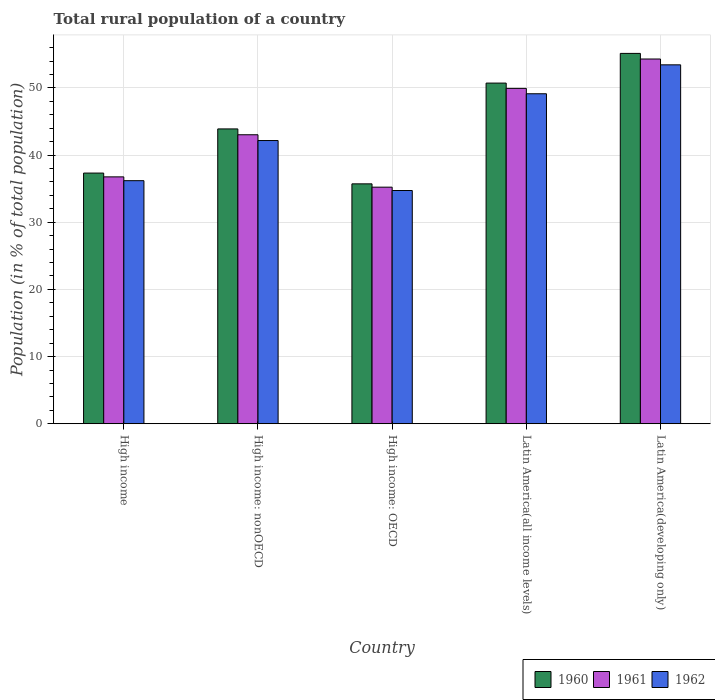How many different coloured bars are there?
Keep it short and to the point. 3. How many groups of bars are there?
Make the answer very short. 5. Are the number of bars per tick equal to the number of legend labels?
Your answer should be very brief. Yes. How many bars are there on the 3rd tick from the right?
Offer a terse response. 3. What is the label of the 4th group of bars from the left?
Keep it short and to the point. Latin America(all income levels). What is the rural population in 1960 in Latin America(all income levels)?
Offer a very short reply. 50.72. Across all countries, what is the maximum rural population in 1961?
Ensure brevity in your answer.  54.3. Across all countries, what is the minimum rural population in 1962?
Keep it short and to the point. 34.72. In which country was the rural population in 1961 maximum?
Give a very brief answer. Latin America(developing only). In which country was the rural population in 1962 minimum?
Offer a very short reply. High income: OECD. What is the total rural population in 1960 in the graph?
Provide a short and direct response. 222.78. What is the difference between the rural population in 1961 in High income and that in Latin America(all income levels)?
Offer a terse response. -13.17. What is the difference between the rural population in 1961 in Latin America(all income levels) and the rural population in 1960 in Latin America(developing only)?
Your answer should be very brief. -5.21. What is the average rural population in 1962 per country?
Your response must be concise. 43.13. What is the difference between the rural population of/in 1962 and rural population of/in 1960 in High income?
Make the answer very short. -1.13. What is the ratio of the rural population in 1961 in High income: OECD to that in Latin America(developing only)?
Your answer should be very brief. 0.65. Is the difference between the rural population in 1962 in High income and Latin America(all income levels) greater than the difference between the rural population in 1960 in High income and Latin America(all income levels)?
Keep it short and to the point. Yes. What is the difference between the highest and the second highest rural population in 1962?
Your response must be concise. 6.97. What is the difference between the highest and the lowest rural population in 1960?
Your answer should be compact. 19.42. In how many countries, is the rural population in 1962 greater than the average rural population in 1962 taken over all countries?
Provide a succinct answer. 2. What does the 1st bar from the left in Latin America(developing only) represents?
Your answer should be compact. 1960. How many countries are there in the graph?
Keep it short and to the point. 5. Are the values on the major ticks of Y-axis written in scientific E-notation?
Your answer should be compact. No. Does the graph contain any zero values?
Make the answer very short. No. How many legend labels are there?
Your answer should be very brief. 3. How are the legend labels stacked?
Your answer should be compact. Horizontal. What is the title of the graph?
Provide a short and direct response. Total rural population of a country. Does "1999" appear as one of the legend labels in the graph?
Give a very brief answer. No. What is the label or title of the X-axis?
Offer a very short reply. Country. What is the label or title of the Y-axis?
Provide a short and direct response. Population (in % of total population). What is the Population (in % of total population) of 1960 in High income?
Make the answer very short. 37.32. What is the Population (in % of total population) of 1961 in High income?
Your answer should be compact. 36.75. What is the Population (in % of total population) in 1962 in High income?
Make the answer very short. 36.19. What is the Population (in % of total population) in 1960 in High income: nonOECD?
Make the answer very short. 43.89. What is the Population (in % of total population) in 1961 in High income: nonOECD?
Keep it short and to the point. 43.02. What is the Population (in % of total population) of 1962 in High income: nonOECD?
Offer a terse response. 42.16. What is the Population (in % of total population) in 1960 in High income: OECD?
Your answer should be very brief. 35.71. What is the Population (in % of total population) of 1961 in High income: OECD?
Your answer should be very brief. 35.22. What is the Population (in % of total population) of 1962 in High income: OECD?
Keep it short and to the point. 34.72. What is the Population (in % of total population) of 1960 in Latin America(all income levels)?
Offer a very short reply. 50.72. What is the Population (in % of total population) of 1961 in Latin America(all income levels)?
Your response must be concise. 49.93. What is the Population (in % of total population) of 1962 in Latin America(all income levels)?
Give a very brief answer. 49.13. What is the Population (in % of total population) of 1960 in Latin America(developing only)?
Your response must be concise. 55.14. What is the Population (in % of total population) of 1961 in Latin America(developing only)?
Keep it short and to the point. 54.3. What is the Population (in % of total population) in 1962 in Latin America(developing only)?
Your answer should be very brief. 53.43. Across all countries, what is the maximum Population (in % of total population) in 1960?
Ensure brevity in your answer.  55.14. Across all countries, what is the maximum Population (in % of total population) of 1961?
Provide a short and direct response. 54.3. Across all countries, what is the maximum Population (in % of total population) in 1962?
Offer a very short reply. 53.43. Across all countries, what is the minimum Population (in % of total population) of 1960?
Your answer should be compact. 35.71. Across all countries, what is the minimum Population (in % of total population) in 1961?
Give a very brief answer. 35.22. Across all countries, what is the minimum Population (in % of total population) of 1962?
Provide a short and direct response. 34.72. What is the total Population (in % of total population) in 1960 in the graph?
Offer a very short reply. 222.78. What is the total Population (in % of total population) of 1961 in the graph?
Offer a terse response. 219.22. What is the total Population (in % of total population) in 1962 in the graph?
Offer a very short reply. 215.63. What is the difference between the Population (in % of total population) in 1960 in High income and that in High income: nonOECD?
Your answer should be very brief. -6.57. What is the difference between the Population (in % of total population) in 1961 in High income and that in High income: nonOECD?
Give a very brief answer. -6.27. What is the difference between the Population (in % of total population) of 1962 in High income and that in High income: nonOECD?
Give a very brief answer. -5.97. What is the difference between the Population (in % of total population) of 1960 in High income and that in High income: OECD?
Make the answer very short. 1.61. What is the difference between the Population (in % of total population) in 1961 in High income and that in High income: OECD?
Provide a succinct answer. 1.53. What is the difference between the Population (in % of total population) of 1962 in High income and that in High income: OECD?
Your answer should be compact. 1.46. What is the difference between the Population (in % of total population) in 1960 in High income and that in Latin America(all income levels)?
Offer a very short reply. -13.4. What is the difference between the Population (in % of total population) in 1961 in High income and that in Latin America(all income levels)?
Make the answer very short. -13.17. What is the difference between the Population (in % of total population) of 1962 in High income and that in Latin America(all income levels)?
Your response must be concise. -12.94. What is the difference between the Population (in % of total population) in 1960 in High income and that in Latin America(developing only)?
Ensure brevity in your answer.  -17.82. What is the difference between the Population (in % of total population) in 1961 in High income and that in Latin America(developing only)?
Give a very brief answer. -17.55. What is the difference between the Population (in % of total population) in 1962 in High income and that in Latin America(developing only)?
Offer a terse response. -17.25. What is the difference between the Population (in % of total population) in 1960 in High income: nonOECD and that in High income: OECD?
Your response must be concise. 8.18. What is the difference between the Population (in % of total population) in 1961 in High income: nonOECD and that in High income: OECD?
Ensure brevity in your answer.  7.8. What is the difference between the Population (in % of total population) in 1962 in High income: nonOECD and that in High income: OECD?
Offer a very short reply. 7.44. What is the difference between the Population (in % of total population) of 1960 in High income: nonOECD and that in Latin America(all income levels)?
Keep it short and to the point. -6.82. What is the difference between the Population (in % of total population) of 1961 in High income: nonOECD and that in Latin America(all income levels)?
Provide a succinct answer. -6.9. What is the difference between the Population (in % of total population) in 1962 in High income: nonOECD and that in Latin America(all income levels)?
Offer a very short reply. -6.97. What is the difference between the Population (in % of total population) of 1960 in High income: nonOECD and that in Latin America(developing only)?
Your answer should be compact. -11.24. What is the difference between the Population (in % of total population) of 1961 in High income: nonOECD and that in Latin America(developing only)?
Your answer should be very brief. -11.28. What is the difference between the Population (in % of total population) of 1962 in High income: nonOECD and that in Latin America(developing only)?
Provide a short and direct response. -11.27. What is the difference between the Population (in % of total population) of 1960 in High income: OECD and that in Latin America(all income levels)?
Keep it short and to the point. -15. What is the difference between the Population (in % of total population) of 1961 in High income: OECD and that in Latin America(all income levels)?
Provide a succinct answer. -14.71. What is the difference between the Population (in % of total population) of 1962 in High income: OECD and that in Latin America(all income levels)?
Offer a very short reply. -14.4. What is the difference between the Population (in % of total population) of 1960 in High income: OECD and that in Latin America(developing only)?
Offer a terse response. -19.42. What is the difference between the Population (in % of total population) of 1961 in High income: OECD and that in Latin America(developing only)?
Your response must be concise. -19.08. What is the difference between the Population (in % of total population) of 1962 in High income: OECD and that in Latin America(developing only)?
Your answer should be very brief. -18.71. What is the difference between the Population (in % of total population) of 1960 in Latin America(all income levels) and that in Latin America(developing only)?
Give a very brief answer. -4.42. What is the difference between the Population (in % of total population) of 1961 in Latin America(all income levels) and that in Latin America(developing only)?
Your response must be concise. -4.37. What is the difference between the Population (in % of total population) of 1962 in Latin America(all income levels) and that in Latin America(developing only)?
Your answer should be compact. -4.31. What is the difference between the Population (in % of total population) in 1960 in High income and the Population (in % of total population) in 1961 in High income: nonOECD?
Offer a very short reply. -5.7. What is the difference between the Population (in % of total population) of 1960 in High income and the Population (in % of total population) of 1962 in High income: nonOECD?
Provide a succinct answer. -4.84. What is the difference between the Population (in % of total population) of 1961 in High income and the Population (in % of total population) of 1962 in High income: nonOECD?
Provide a succinct answer. -5.41. What is the difference between the Population (in % of total population) in 1960 in High income and the Population (in % of total population) in 1961 in High income: OECD?
Ensure brevity in your answer.  2.1. What is the difference between the Population (in % of total population) in 1960 in High income and the Population (in % of total population) in 1962 in High income: OECD?
Make the answer very short. 2.6. What is the difference between the Population (in % of total population) in 1961 in High income and the Population (in % of total population) in 1962 in High income: OECD?
Your answer should be very brief. 2.03. What is the difference between the Population (in % of total population) of 1960 in High income and the Population (in % of total population) of 1961 in Latin America(all income levels)?
Your response must be concise. -12.61. What is the difference between the Population (in % of total population) in 1960 in High income and the Population (in % of total population) in 1962 in Latin America(all income levels)?
Keep it short and to the point. -11.81. What is the difference between the Population (in % of total population) in 1961 in High income and the Population (in % of total population) in 1962 in Latin America(all income levels)?
Keep it short and to the point. -12.37. What is the difference between the Population (in % of total population) in 1960 in High income and the Population (in % of total population) in 1961 in Latin America(developing only)?
Offer a very short reply. -16.98. What is the difference between the Population (in % of total population) in 1960 in High income and the Population (in % of total population) in 1962 in Latin America(developing only)?
Provide a short and direct response. -16.11. What is the difference between the Population (in % of total population) in 1961 in High income and the Population (in % of total population) in 1962 in Latin America(developing only)?
Offer a very short reply. -16.68. What is the difference between the Population (in % of total population) in 1960 in High income: nonOECD and the Population (in % of total population) in 1961 in High income: OECD?
Your response must be concise. 8.67. What is the difference between the Population (in % of total population) in 1960 in High income: nonOECD and the Population (in % of total population) in 1962 in High income: OECD?
Give a very brief answer. 9.17. What is the difference between the Population (in % of total population) in 1961 in High income: nonOECD and the Population (in % of total population) in 1962 in High income: OECD?
Provide a succinct answer. 8.3. What is the difference between the Population (in % of total population) of 1960 in High income: nonOECD and the Population (in % of total population) of 1961 in Latin America(all income levels)?
Provide a short and direct response. -6.03. What is the difference between the Population (in % of total population) in 1960 in High income: nonOECD and the Population (in % of total population) in 1962 in Latin America(all income levels)?
Your answer should be compact. -5.24. What is the difference between the Population (in % of total population) of 1961 in High income: nonOECD and the Population (in % of total population) of 1962 in Latin America(all income levels)?
Make the answer very short. -6.1. What is the difference between the Population (in % of total population) of 1960 in High income: nonOECD and the Population (in % of total population) of 1961 in Latin America(developing only)?
Offer a very short reply. -10.41. What is the difference between the Population (in % of total population) of 1960 in High income: nonOECD and the Population (in % of total population) of 1962 in Latin America(developing only)?
Make the answer very short. -9.54. What is the difference between the Population (in % of total population) in 1961 in High income: nonOECD and the Population (in % of total population) in 1962 in Latin America(developing only)?
Your response must be concise. -10.41. What is the difference between the Population (in % of total population) of 1960 in High income: OECD and the Population (in % of total population) of 1961 in Latin America(all income levels)?
Your response must be concise. -14.21. What is the difference between the Population (in % of total population) of 1960 in High income: OECD and the Population (in % of total population) of 1962 in Latin America(all income levels)?
Ensure brevity in your answer.  -13.41. What is the difference between the Population (in % of total population) of 1961 in High income: OECD and the Population (in % of total population) of 1962 in Latin America(all income levels)?
Offer a very short reply. -13.91. What is the difference between the Population (in % of total population) of 1960 in High income: OECD and the Population (in % of total population) of 1961 in Latin America(developing only)?
Your answer should be compact. -18.59. What is the difference between the Population (in % of total population) in 1960 in High income: OECD and the Population (in % of total population) in 1962 in Latin America(developing only)?
Keep it short and to the point. -17.72. What is the difference between the Population (in % of total population) in 1961 in High income: OECD and the Population (in % of total population) in 1962 in Latin America(developing only)?
Give a very brief answer. -18.21. What is the difference between the Population (in % of total population) in 1960 in Latin America(all income levels) and the Population (in % of total population) in 1961 in Latin America(developing only)?
Provide a short and direct response. -3.58. What is the difference between the Population (in % of total population) of 1960 in Latin America(all income levels) and the Population (in % of total population) of 1962 in Latin America(developing only)?
Keep it short and to the point. -2.72. What is the difference between the Population (in % of total population) in 1961 in Latin America(all income levels) and the Population (in % of total population) in 1962 in Latin America(developing only)?
Make the answer very short. -3.51. What is the average Population (in % of total population) of 1960 per country?
Your answer should be compact. 44.56. What is the average Population (in % of total population) of 1961 per country?
Ensure brevity in your answer.  43.84. What is the average Population (in % of total population) of 1962 per country?
Your answer should be compact. 43.13. What is the difference between the Population (in % of total population) in 1960 and Population (in % of total population) in 1961 in High income?
Your answer should be very brief. 0.57. What is the difference between the Population (in % of total population) of 1960 and Population (in % of total population) of 1962 in High income?
Provide a succinct answer. 1.13. What is the difference between the Population (in % of total population) in 1961 and Population (in % of total population) in 1962 in High income?
Offer a terse response. 0.57. What is the difference between the Population (in % of total population) of 1960 and Population (in % of total population) of 1961 in High income: nonOECD?
Provide a succinct answer. 0.87. What is the difference between the Population (in % of total population) in 1960 and Population (in % of total population) in 1962 in High income: nonOECD?
Offer a terse response. 1.73. What is the difference between the Population (in % of total population) in 1961 and Population (in % of total population) in 1962 in High income: nonOECD?
Your answer should be compact. 0.86. What is the difference between the Population (in % of total population) of 1960 and Population (in % of total population) of 1961 in High income: OECD?
Provide a succinct answer. 0.49. What is the difference between the Population (in % of total population) in 1960 and Population (in % of total population) in 1962 in High income: OECD?
Give a very brief answer. 0.99. What is the difference between the Population (in % of total population) of 1961 and Population (in % of total population) of 1962 in High income: OECD?
Your response must be concise. 0.5. What is the difference between the Population (in % of total population) of 1960 and Population (in % of total population) of 1961 in Latin America(all income levels)?
Provide a short and direct response. 0.79. What is the difference between the Population (in % of total population) in 1960 and Population (in % of total population) in 1962 in Latin America(all income levels)?
Your answer should be compact. 1.59. What is the difference between the Population (in % of total population) of 1961 and Population (in % of total population) of 1962 in Latin America(all income levels)?
Give a very brief answer. 0.8. What is the difference between the Population (in % of total population) in 1960 and Population (in % of total population) in 1961 in Latin America(developing only)?
Ensure brevity in your answer.  0.84. What is the difference between the Population (in % of total population) in 1960 and Population (in % of total population) in 1962 in Latin America(developing only)?
Provide a short and direct response. 1.7. What is the difference between the Population (in % of total population) in 1961 and Population (in % of total population) in 1962 in Latin America(developing only)?
Offer a terse response. 0.87. What is the ratio of the Population (in % of total population) in 1960 in High income to that in High income: nonOECD?
Your answer should be very brief. 0.85. What is the ratio of the Population (in % of total population) in 1961 in High income to that in High income: nonOECD?
Keep it short and to the point. 0.85. What is the ratio of the Population (in % of total population) in 1962 in High income to that in High income: nonOECD?
Offer a terse response. 0.86. What is the ratio of the Population (in % of total population) of 1960 in High income to that in High income: OECD?
Your response must be concise. 1.04. What is the ratio of the Population (in % of total population) of 1961 in High income to that in High income: OECD?
Keep it short and to the point. 1.04. What is the ratio of the Population (in % of total population) in 1962 in High income to that in High income: OECD?
Your answer should be very brief. 1.04. What is the ratio of the Population (in % of total population) of 1960 in High income to that in Latin America(all income levels)?
Your response must be concise. 0.74. What is the ratio of the Population (in % of total population) in 1961 in High income to that in Latin America(all income levels)?
Your answer should be very brief. 0.74. What is the ratio of the Population (in % of total population) in 1962 in High income to that in Latin America(all income levels)?
Provide a succinct answer. 0.74. What is the ratio of the Population (in % of total population) in 1960 in High income to that in Latin America(developing only)?
Make the answer very short. 0.68. What is the ratio of the Population (in % of total population) of 1961 in High income to that in Latin America(developing only)?
Your answer should be very brief. 0.68. What is the ratio of the Population (in % of total population) of 1962 in High income to that in Latin America(developing only)?
Offer a very short reply. 0.68. What is the ratio of the Population (in % of total population) in 1960 in High income: nonOECD to that in High income: OECD?
Keep it short and to the point. 1.23. What is the ratio of the Population (in % of total population) in 1961 in High income: nonOECD to that in High income: OECD?
Provide a succinct answer. 1.22. What is the ratio of the Population (in % of total population) of 1962 in High income: nonOECD to that in High income: OECD?
Ensure brevity in your answer.  1.21. What is the ratio of the Population (in % of total population) in 1960 in High income: nonOECD to that in Latin America(all income levels)?
Your answer should be very brief. 0.87. What is the ratio of the Population (in % of total population) of 1961 in High income: nonOECD to that in Latin America(all income levels)?
Ensure brevity in your answer.  0.86. What is the ratio of the Population (in % of total population) of 1962 in High income: nonOECD to that in Latin America(all income levels)?
Your answer should be compact. 0.86. What is the ratio of the Population (in % of total population) in 1960 in High income: nonOECD to that in Latin America(developing only)?
Keep it short and to the point. 0.8. What is the ratio of the Population (in % of total population) of 1961 in High income: nonOECD to that in Latin America(developing only)?
Your answer should be very brief. 0.79. What is the ratio of the Population (in % of total population) of 1962 in High income: nonOECD to that in Latin America(developing only)?
Your response must be concise. 0.79. What is the ratio of the Population (in % of total population) of 1960 in High income: OECD to that in Latin America(all income levels)?
Ensure brevity in your answer.  0.7. What is the ratio of the Population (in % of total population) of 1961 in High income: OECD to that in Latin America(all income levels)?
Your answer should be compact. 0.71. What is the ratio of the Population (in % of total population) of 1962 in High income: OECD to that in Latin America(all income levels)?
Your response must be concise. 0.71. What is the ratio of the Population (in % of total population) in 1960 in High income: OECD to that in Latin America(developing only)?
Your answer should be very brief. 0.65. What is the ratio of the Population (in % of total population) of 1961 in High income: OECD to that in Latin America(developing only)?
Offer a terse response. 0.65. What is the ratio of the Population (in % of total population) in 1962 in High income: OECD to that in Latin America(developing only)?
Ensure brevity in your answer.  0.65. What is the ratio of the Population (in % of total population) in 1960 in Latin America(all income levels) to that in Latin America(developing only)?
Give a very brief answer. 0.92. What is the ratio of the Population (in % of total population) of 1961 in Latin America(all income levels) to that in Latin America(developing only)?
Offer a very short reply. 0.92. What is the ratio of the Population (in % of total population) of 1962 in Latin America(all income levels) to that in Latin America(developing only)?
Offer a terse response. 0.92. What is the difference between the highest and the second highest Population (in % of total population) of 1960?
Offer a very short reply. 4.42. What is the difference between the highest and the second highest Population (in % of total population) in 1961?
Offer a very short reply. 4.37. What is the difference between the highest and the second highest Population (in % of total population) of 1962?
Keep it short and to the point. 4.31. What is the difference between the highest and the lowest Population (in % of total population) of 1960?
Your answer should be compact. 19.42. What is the difference between the highest and the lowest Population (in % of total population) of 1961?
Ensure brevity in your answer.  19.08. What is the difference between the highest and the lowest Population (in % of total population) of 1962?
Make the answer very short. 18.71. 